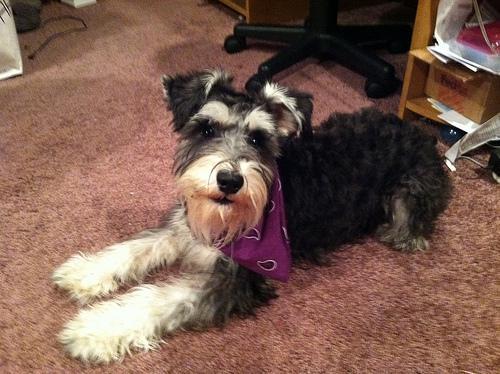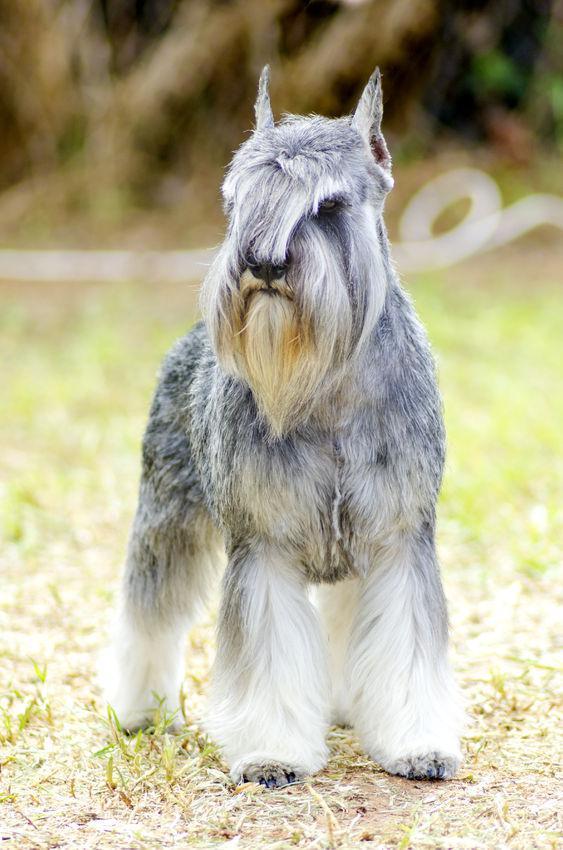The first image is the image on the left, the second image is the image on the right. Considering the images on both sides, is "the dog in the image on the right is wearing a collar" valid? Answer yes or no. No. The first image is the image on the left, the second image is the image on the right. Analyze the images presented: Is the assertion "Schnauzer in the left image is wearing a kind of bandana around its neck." valid? Answer yes or no. Yes. 